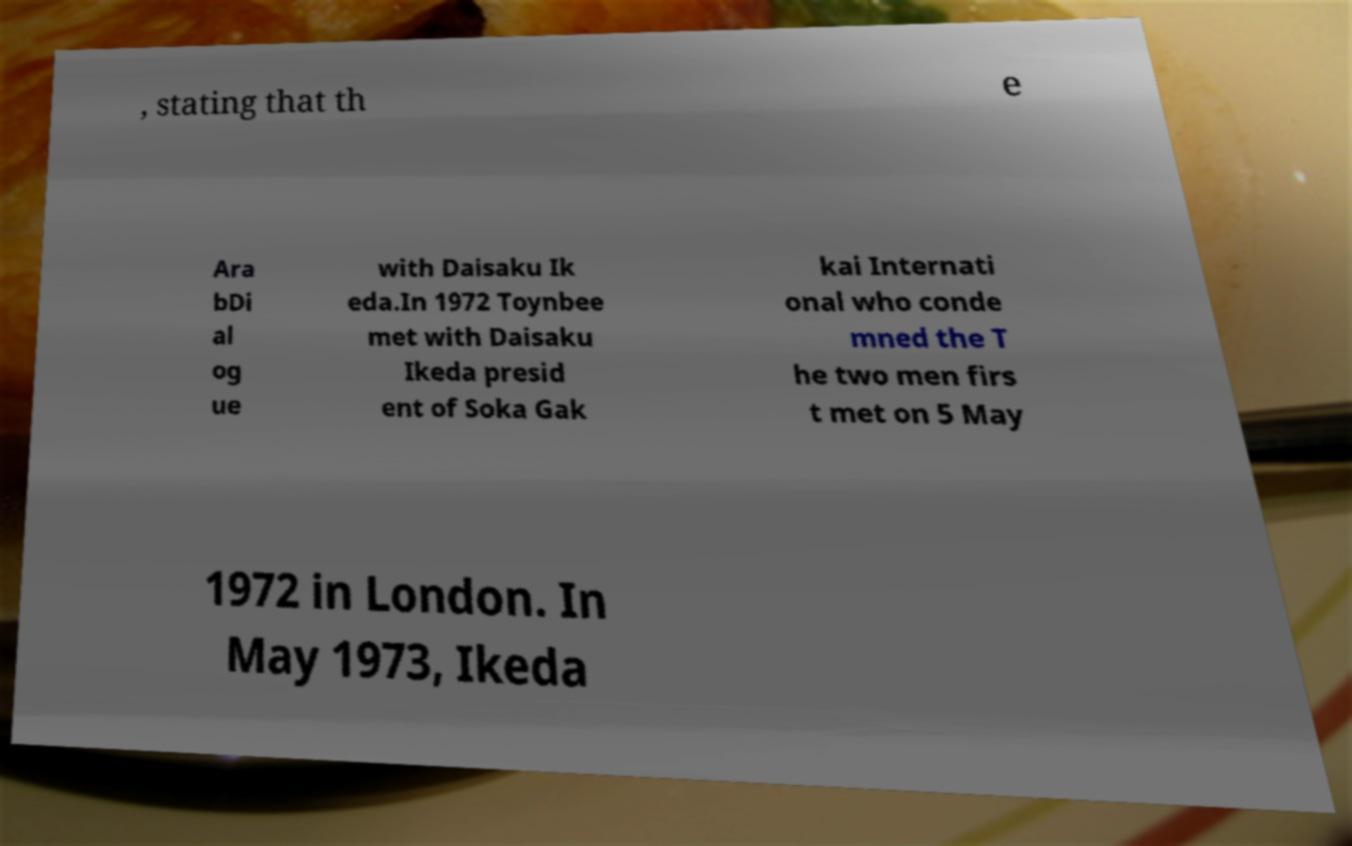I need the written content from this picture converted into text. Can you do that? , stating that th e Ara bDi al og ue with Daisaku Ik eda.In 1972 Toynbee met with Daisaku Ikeda presid ent of Soka Gak kai Internati onal who conde mned the T he two men firs t met on 5 May 1972 in London. In May 1973, Ikeda 